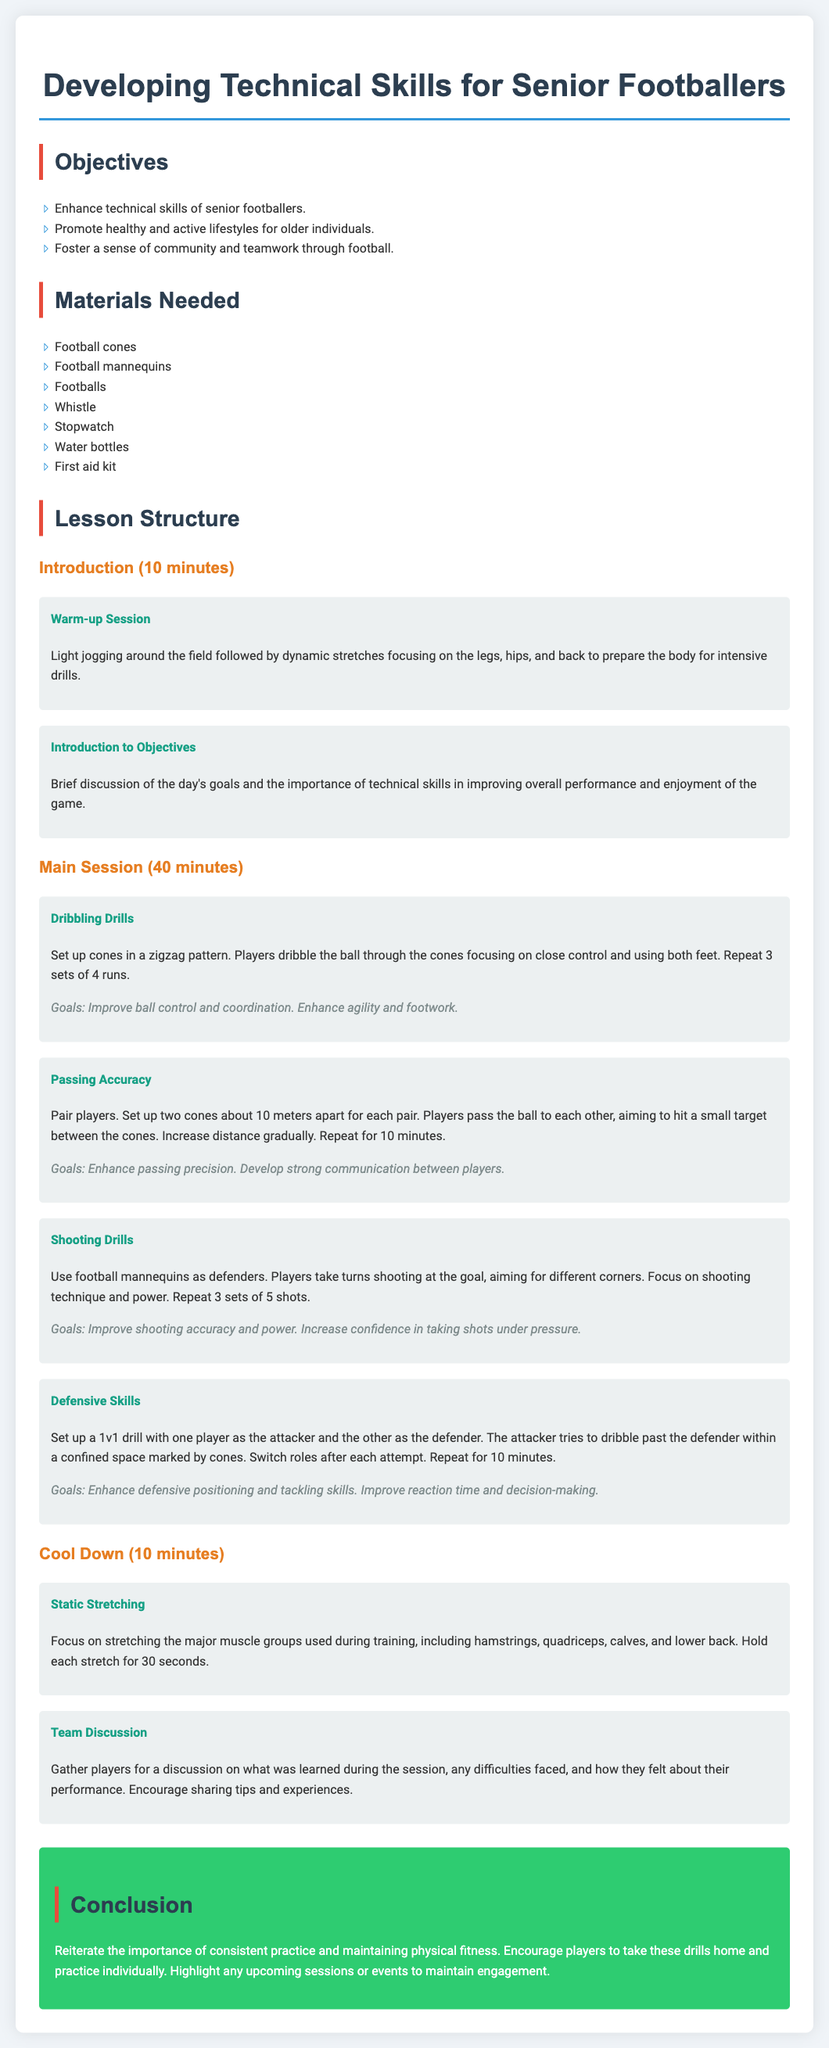what is the main goal of the session? The main goals of the session are to enhance technical skills, promote healthy lifestyles, and foster teamwork.
Answer: enhance technical skills of senior footballers how long does the main session last? The main session duration is specified in the document.
Answer: 40 minutes what materials are needed for the drills? The lesson plan lists several materials needed for the activities.
Answer: football cones how many players participate in the passing accuracy drill? The drill requires a specific arrangement of players.
Answer: pair players what is the focus of the shooting drills? The objectives of the shooting drills are mentioned in the document.
Answer: improve shooting accuracy and power which activity includes dynamic stretches? The specific activity that prepares players for intensive drills is listed in the introduction.
Answer: Warm-up Session how many sets are recommended for dribbling drills? The lesson plan includes the recommended repetitions for the dribbling activity.
Answer: 3 sets of 4 runs what should players discuss during the team discussion? The content of the team discussion is encouraged in the document.
Answer: what was learned during the session what is the cooldown activity focused on? The cooldown activities aim to address particular aspects of physical recovery.
Answer: static stretching 